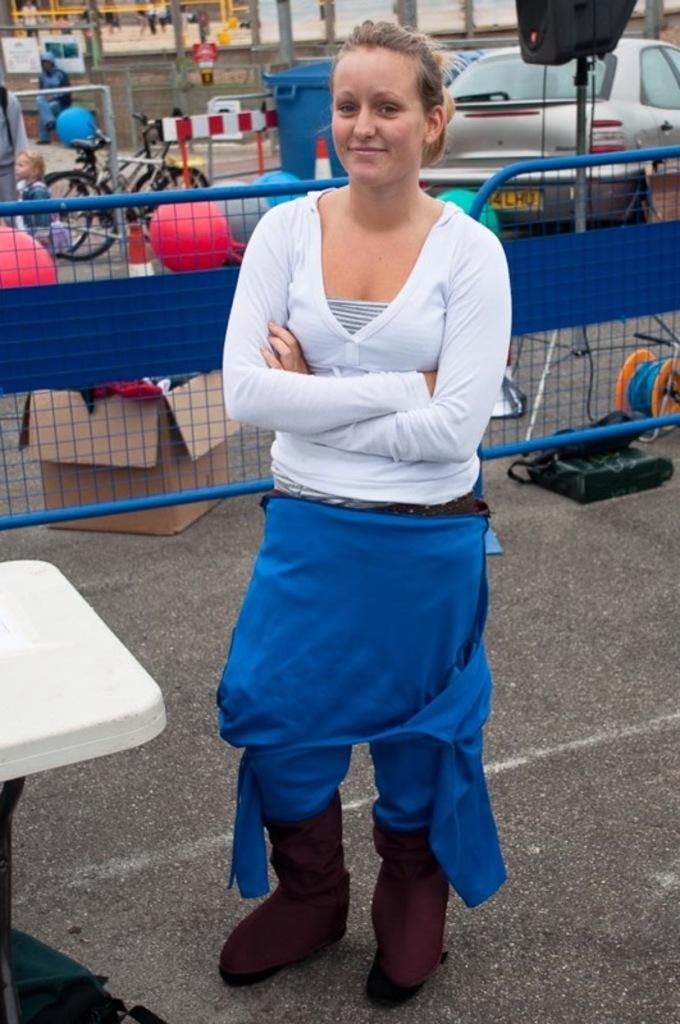Who is present in the image? There is a woman in the image. What is the woman wearing? The woman is wearing a white shirt. What is the woman doing in the image? The woman is standing. What can be seen in the background of the image? There is a blue barrier in the image. What other vehicles are present in the image? There is a car and bicycles in the image. What type of feast is being prepared in the image? There is no feast being prepared in the image; it features a woman standing near a blue barrier with a car and bicycles in the background. 